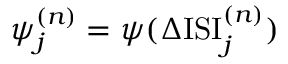Convert formula to latex. <formula><loc_0><loc_0><loc_500><loc_500>\psi _ { j } ^ { ( n ) } = \psi ( \Delta I S I _ { j } ^ { ( n ) } )</formula> 